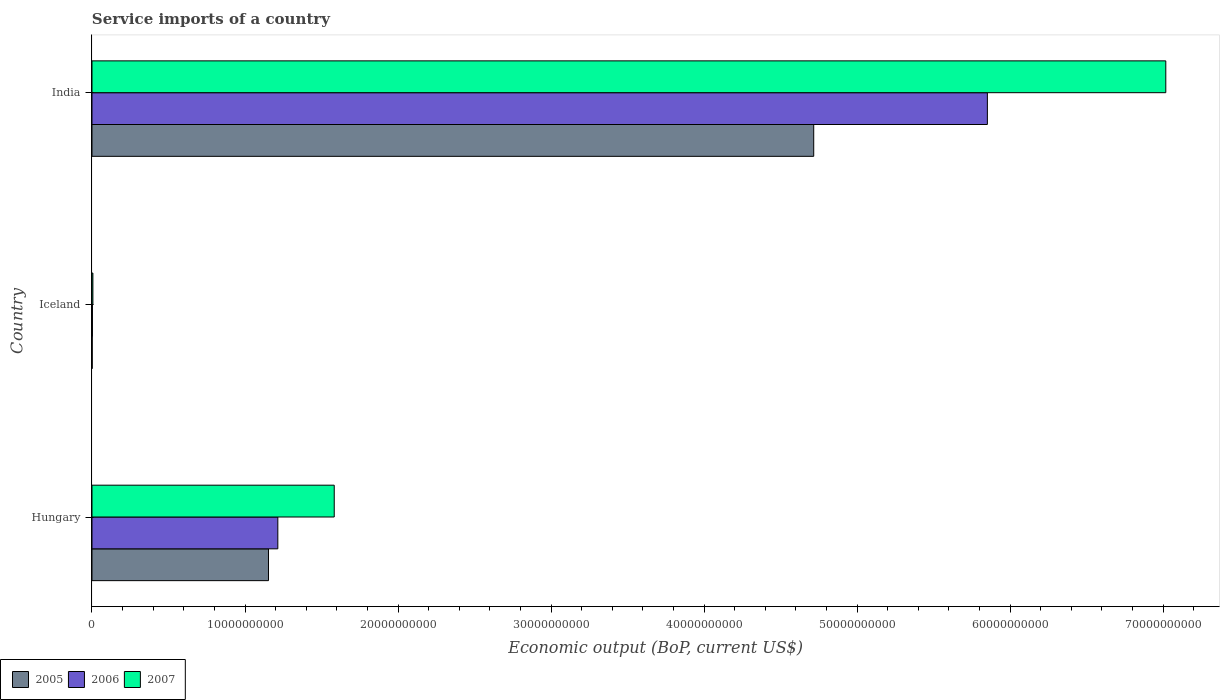How many bars are there on the 2nd tick from the top?
Ensure brevity in your answer.  3. In how many cases, is the number of bars for a given country not equal to the number of legend labels?
Make the answer very short. 0. What is the service imports in 2005 in Iceland?
Give a very brief answer. 1.32e+07. Across all countries, what is the maximum service imports in 2007?
Offer a very short reply. 7.02e+1. Across all countries, what is the minimum service imports in 2005?
Your answer should be very brief. 1.32e+07. What is the total service imports in 2005 in the graph?
Make the answer very short. 5.87e+1. What is the difference between the service imports in 2007 in Iceland and that in India?
Make the answer very short. -7.01e+1. What is the difference between the service imports in 2006 in India and the service imports in 2007 in Iceland?
Ensure brevity in your answer.  5.85e+1. What is the average service imports in 2005 per country?
Your answer should be very brief. 1.96e+1. What is the difference between the service imports in 2006 and service imports in 2005 in Hungary?
Your response must be concise. 6.10e+08. What is the ratio of the service imports in 2005 in Hungary to that in India?
Offer a terse response. 0.24. Is the difference between the service imports in 2006 in Hungary and India greater than the difference between the service imports in 2005 in Hungary and India?
Offer a very short reply. No. What is the difference between the highest and the second highest service imports in 2006?
Provide a short and direct response. 4.64e+1. What is the difference between the highest and the lowest service imports in 2006?
Provide a short and direct response. 5.85e+1. In how many countries, is the service imports in 2006 greater than the average service imports in 2006 taken over all countries?
Offer a terse response. 1. Is the sum of the service imports in 2005 in Iceland and India greater than the maximum service imports in 2006 across all countries?
Offer a terse response. No. What does the 1st bar from the bottom in India represents?
Your response must be concise. 2005. Is it the case that in every country, the sum of the service imports in 2007 and service imports in 2005 is greater than the service imports in 2006?
Offer a very short reply. Yes. Are all the bars in the graph horizontal?
Your answer should be compact. Yes. How many countries are there in the graph?
Offer a very short reply. 3. What is the difference between two consecutive major ticks on the X-axis?
Provide a succinct answer. 1.00e+1. Does the graph contain any zero values?
Your response must be concise. No. What is the title of the graph?
Offer a very short reply. Service imports of a country. Does "2005" appear as one of the legend labels in the graph?
Offer a very short reply. Yes. What is the label or title of the X-axis?
Make the answer very short. Economic output (BoP, current US$). What is the Economic output (BoP, current US$) of 2005 in Hungary?
Ensure brevity in your answer.  1.15e+1. What is the Economic output (BoP, current US$) in 2006 in Hungary?
Your answer should be very brief. 1.21e+1. What is the Economic output (BoP, current US$) in 2007 in Hungary?
Give a very brief answer. 1.58e+1. What is the Economic output (BoP, current US$) in 2005 in Iceland?
Offer a very short reply. 1.32e+07. What is the Economic output (BoP, current US$) in 2006 in Iceland?
Your response must be concise. 2.89e+07. What is the Economic output (BoP, current US$) of 2007 in Iceland?
Ensure brevity in your answer.  5.90e+07. What is the Economic output (BoP, current US$) in 2005 in India?
Offer a terse response. 4.72e+1. What is the Economic output (BoP, current US$) of 2006 in India?
Keep it short and to the point. 5.85e+1. What is the Economic output (BoP, current US$) in 2007 in India?
Ensure brevity in your answer.  7.02e+1. Across all countries, what is the maximum Economic output (BoP, current US$) in 2005?
Your response must be concise. 4.72e+1. Across all countries, what is the maximum Economic output (BoP, current US$) in 2006?
Provide a short and direct response. 5.85e+1. Across all countries, what is the maximum Economic output (BoP, current US$) in 2007?
Offer a very short reply. 7.02e+1. Across all countries, what is the minimum Economic output (BoP, current US$) in 2005?
Keep it short and to the point. 1.32e+07. Across all countries, what is the minimum Economic output (BoP, current US$) of 2006?
Ensure brevity in your answer.  2.89e+07. Across all countries, what is the minimum Economic output (BoP, current US$) of 2007?
Offer a terse response. 5.90e+07. What is the total Economic output (BoP, current US$) of 2005 in the graph?
Keep it short and to the point. 5.87e+1. What is the total Economic output (BoP, current US$) of 2006 in the graph?
Make the answer very short. 7.07e+1. What is the total Economic output (BoP, current US$) in 2007 in the graph?
Offer a very short reply. 8.61e+1. What is the difference between the Economic output (BoP, current US$) of 2005 in Hungary and that in Iceland?
Your answer should be compact. 1.15e+1. What is the difference between the Economic output (BoP, current US$) of 2006 in Hungary and that in Iceland?
Your response must be concise. 1.21e+1. What is the difference between the Economic output (BoP, current US$) in 2007 in Hungary and that in Iceland?
Provide a short and direct response. 1.58e+1. What is the difference between the Economic output (BoP, current US$) in 2005 in Hungary and that in India?
Give a very brief answer. -3.56e+1. What is the difference between the Economic output (BoP, current US$) of 2006 in Hungary and that in India?
Offer a very short reply. -4.64e+1. What is the difference between the Economic output (BoP, current US$) of 2007 in Hungary and that in India?
Provide a short and direct response. -5.43e+1. What is the difference between the Economic output (BoP, current US$) in 2005 in Iceland and that in India?
Make the answer very short. -4.72e+1. What is the difference between the Economic output (BoP, current US$) in 2006 in Iceland and that in India?
Ensure brevity in your answer.  -5.85e+1. What is the difference between the Economic output (BoP, current US$) in 2007 in Iceland and that in India?
Your response must be concise. -7.01e+1. What is the difference between the Economic output (BoP, current US$) of 2005 in Hungary and the Economic output (BoP, current US$) of 2006 in Iceland?
Give a very brief answer. 1.15e+1. What is the difference between the Economic output (BoP, current US$) of 2005 in Hungary and the Economic output (BoP, current US$) of 2007 in Iceland?
Make the answer very short. 1.15e+1. What is the difference between the Economic output (BoP, current US$) in 2006 in Hungary and the Economic output (BoP, current US$) in 2007 in Iceland?
Your response must be concise. 1.21e+1. What is the difference between the Economic output (BoP, current US$) of 2005 in Hungary and the Economic output (BoP, current US$) of 2006 in India?
Provide a short and direct response. -4.70e+1. What is the difference between the Economic output (BoP, current US$) of 2005 in Hungary and the Economic output (BoP, current US$) of 2007 in India?
Provide a short and direct response. -5.86e+1. What is the difference between the Economic output (BoP, current US$) of 2006 in Hungary and the Economic output (BoP, current US$) of 2007 in India?
Ensure brevity in your answer.  -5.80e+1. What is the difference between the Economic output (BoP, current US$) of 2005 in Iceland and the Economic output (BoP, current US$) of 2006 in India?
Provide a short and direct response. -5.85e+1. What is the difference between the Economic output (BoP, current US$) in 2005 in Iceland and the Economic output (BoP, current US$) in 2007 in India?
Your answer should be compact. -7.02e+1. What is the difference between the Economic output (BoP, current US$) of 2006 in Iceland and the Economic output (BoP, current US$) of 2007 in India?
Ensure brevity in your answer.  -7.01e+1. What is the average Economic output (BoP, current US$) in 2005 per country?
Give a very brief answer. 1.96e+1. What is the average Economic output (BoP, current US$) of 2006 per country?
Keep it short and to the point. 2.36e+1. What is the average Economic output (BoP, current US$) in 2007 per country?
Provide a short and direct response. 2.87e+1. What is the difference between the Economic output (BoP, current US$) in 2005 and Economic output (BoP, current US$) in 2006 in Hungary?
Provide a short and direct response. -6.10e+08. What is the difference between the Economic output (BoP, current US$) in 2005 and Economic output (BoP, current US$) in 2007 in Hungary?
Make the answer very short. -4.30e+09. What is the difference between the Economic output (BoP, current US$) in 2006 and Economic output (BoP, current US$) in 2007 in Hungary?
Your answer should be compact. -3.69e+09. What is the difference between the Economic output (BoP, current US$) in 2005 and Economic output (BoP, current US$) in 2006 in Iceland?
Your answer should be compact. -1.57e+07. What is the difference between the Economic output (BoP, current US$) of 2005 and Economic output (BoP, current US$) of 2007 in Iceland?
Provide a succinct answer. -4.58e+07. What is the difference between the Economic output (BoP, current US$) of 2006 and Economic output (BoP, current US$) of 2007 in Iceland?
Make the answer very short. -3.01e+07. What is the difference between the Economic output (BoP, current US$) of 2005 and Economic output (BoP, current US$) of 2006 in India?
Your response must be concise. -1.13e+1. What is the difference between the Economic output (BoP, current US$) of 2005 and Economic output (BoP, current US$) of 2007 in India?
Offer a very short reply. -2.30e+1. What is the difference between the Economic output (BoP, current US$) of 2006 and Economic output (BoP, current US$) of 2007 in India?
Offer a very short reply. -1.17e+1. What is the ratio of the Economic output (BoP, current US$) in 2005 in Hungary to that in Iceland?
Keep it short and to the point. 871.84. What is the ratio of the Economic output (BoP, current US$) in 2006 in Hungary to that in Iceland?
Make the answer very short. 419.96. What is the ratio of the Economic output (BoP, current US$) of 2007 in Hungary to that in Iceland?
Your answer should be very brief. 268.36. What is the ratio of the Economic output (BoP, current US$) of 2005 in Hungary to that in India?
Ensure brevity in your answer.  0.24. What is the ratio of the Economic output (BoP, current US$) in 2006 in Hungary to that in India?
Make the answer very short. 0.21. What is the ratio of the Economic output (BoP, current US$) in 2007 in Hungary to that in India?
Make the answer very short. 0.23. What is the ratio of the Economic output (BoP, current US$) in 2006 in Iceland to that in India?
Your answer should be compact. 0. What is the ratio of the Economic output (BoP, current US$) of 2007 in Iceland to that in India?
Offer a very short reply. 0. What is the difference between the highest and the second highest Economic output (BoP, current US$) in 2005?
Keep it short and to the point. 3.56e+1. What is the difference between the highest and the second highest Economic output (BoP, current US$) in 2006?
Give a very brief answer. 4.64e+1. What is the difference between the highest and the second highest Economic output (BoP, current US$) of 2007?
Your response must be concise. 5.43e+1. What is the difference between the highest and the lowest Economic output (BoP, current US$) in 2005?
Offer a very short reply. 4.72e+1. What is the difference between the highest and the lowest Economic output (BoP, current US$) of 2006?
Your answer should be very brief. 5.85e+1. What is the difference between the highest and the lowest Economic output (BoP, current US$) of 2007?
Keep it short and to the point. 7.01e+1. 